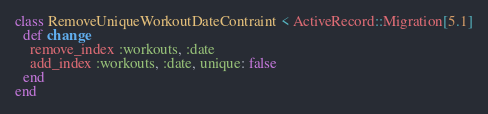Convert code to text. <code><loc_0><loc_0><loc_500><loc_500><_Ruby_>class RemoveUniqueWorkoutDateContraint < ActiveRecord::Migration[5.1]
  def change
    remove_index :workouts, :date
    add_index :workouts, :date, unique: false
  end
end
</code> 